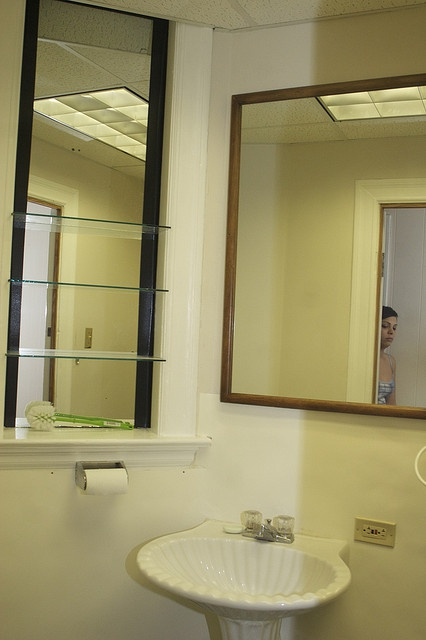Describe the objects in this image and their specific colors. I can see sink in olive and tan tones and people in olive, gray, maroon, and black tones in this image. 